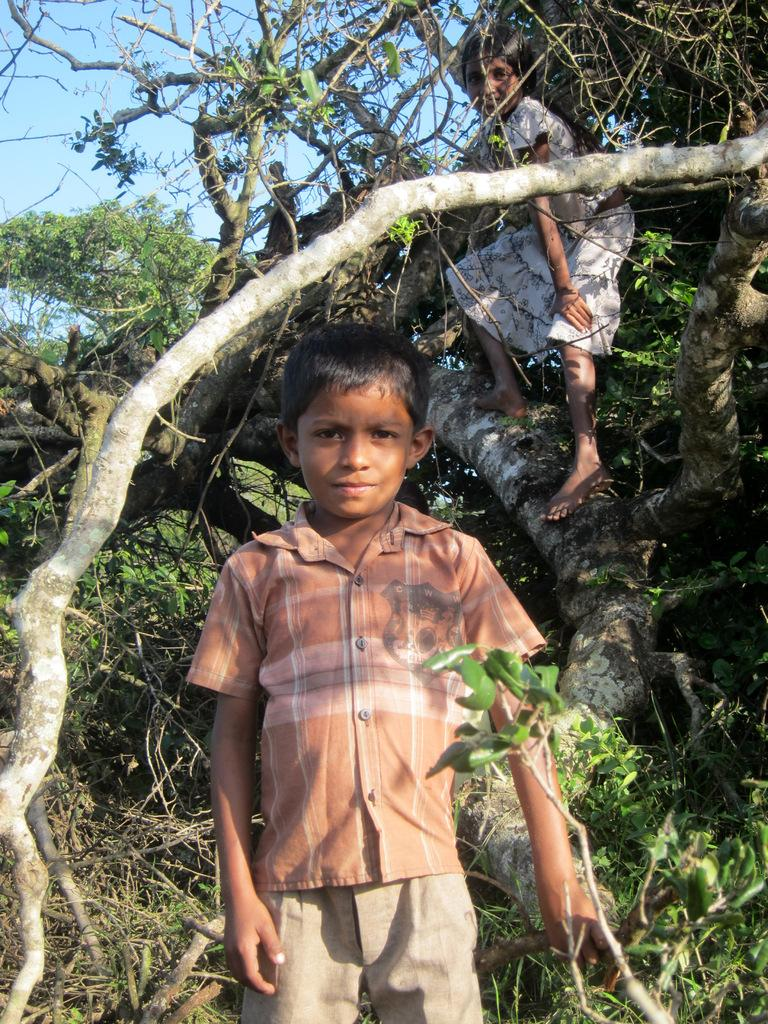Who are the people in the image? There is a boy and a girl in the image. What is the girl doing in the image? The girl is standing on a tree. What can be seen in the background of the image? There are trees visible in the background of the image. What type of disgust can be seen on the boy's face in the image? There is no indication of disgust on the boy's face in the image. 